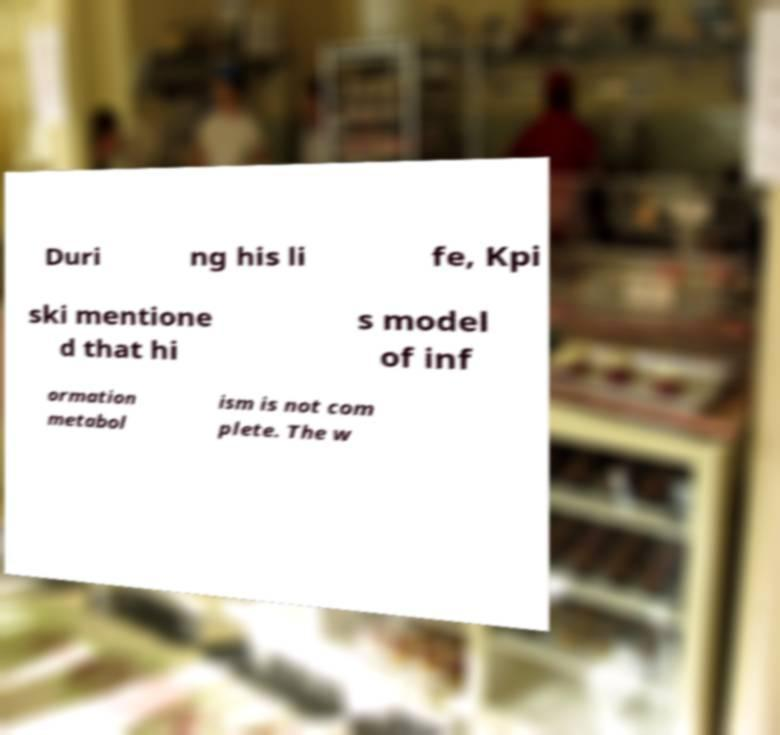I need the written content from this picture converted into text. Can you do that? Duri ng his li fe, Kpi ski mentione d that hi s model of inf ormation metabol ism is not com plete. The w 